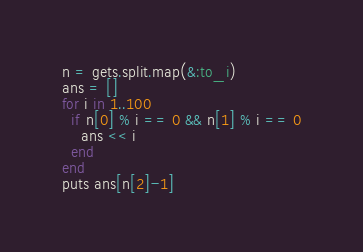<code> <loc_0><loc_0><loc_500><loc_500><_Ruby_>n = gets.split.map(&:to_i)
ans = []
for i in 1..100
  if n[0] % i == 0 && n[1] % i == 0
    ans << i
  end
end
puts ans[n[2]-1]
</code> 